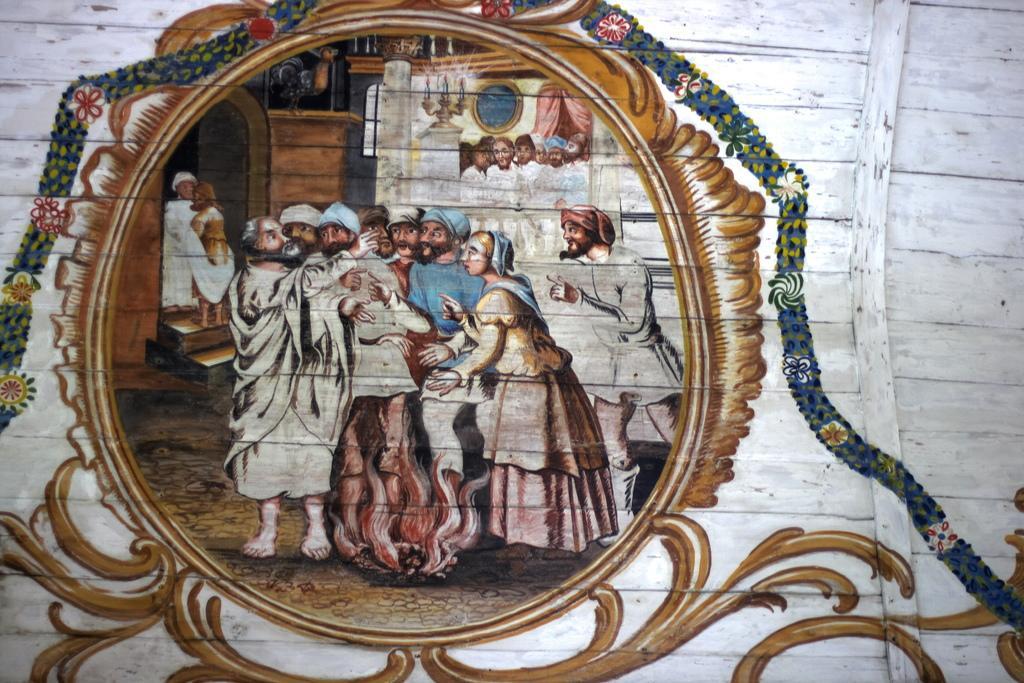In one or two sentences, can you explain what this image depicts? In this image there is a painting of flowers, people , candles with a candle stand , frame attached to the wall , on the wooden object. 